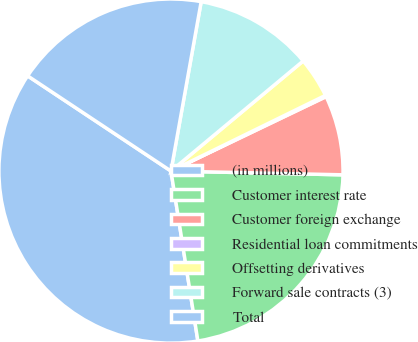<chart> <loc_0><loc_0><loc_500><loc_500><pie_chart><fcel>(in millions)<fcel>Customer interest rate<fcel>Customer foreign exchange<fcel>Residential loan commitments<fcel>Offsetting derivatives<fcel>Forward sale contracts (3)<fcel>Total<nl><fcel>36.83%<fcel>22.15%<fcel>7.47%<fcel>0.13%<fcel>3.8%<fcel>11.14%<fcel>18.48%<nl></chart> 